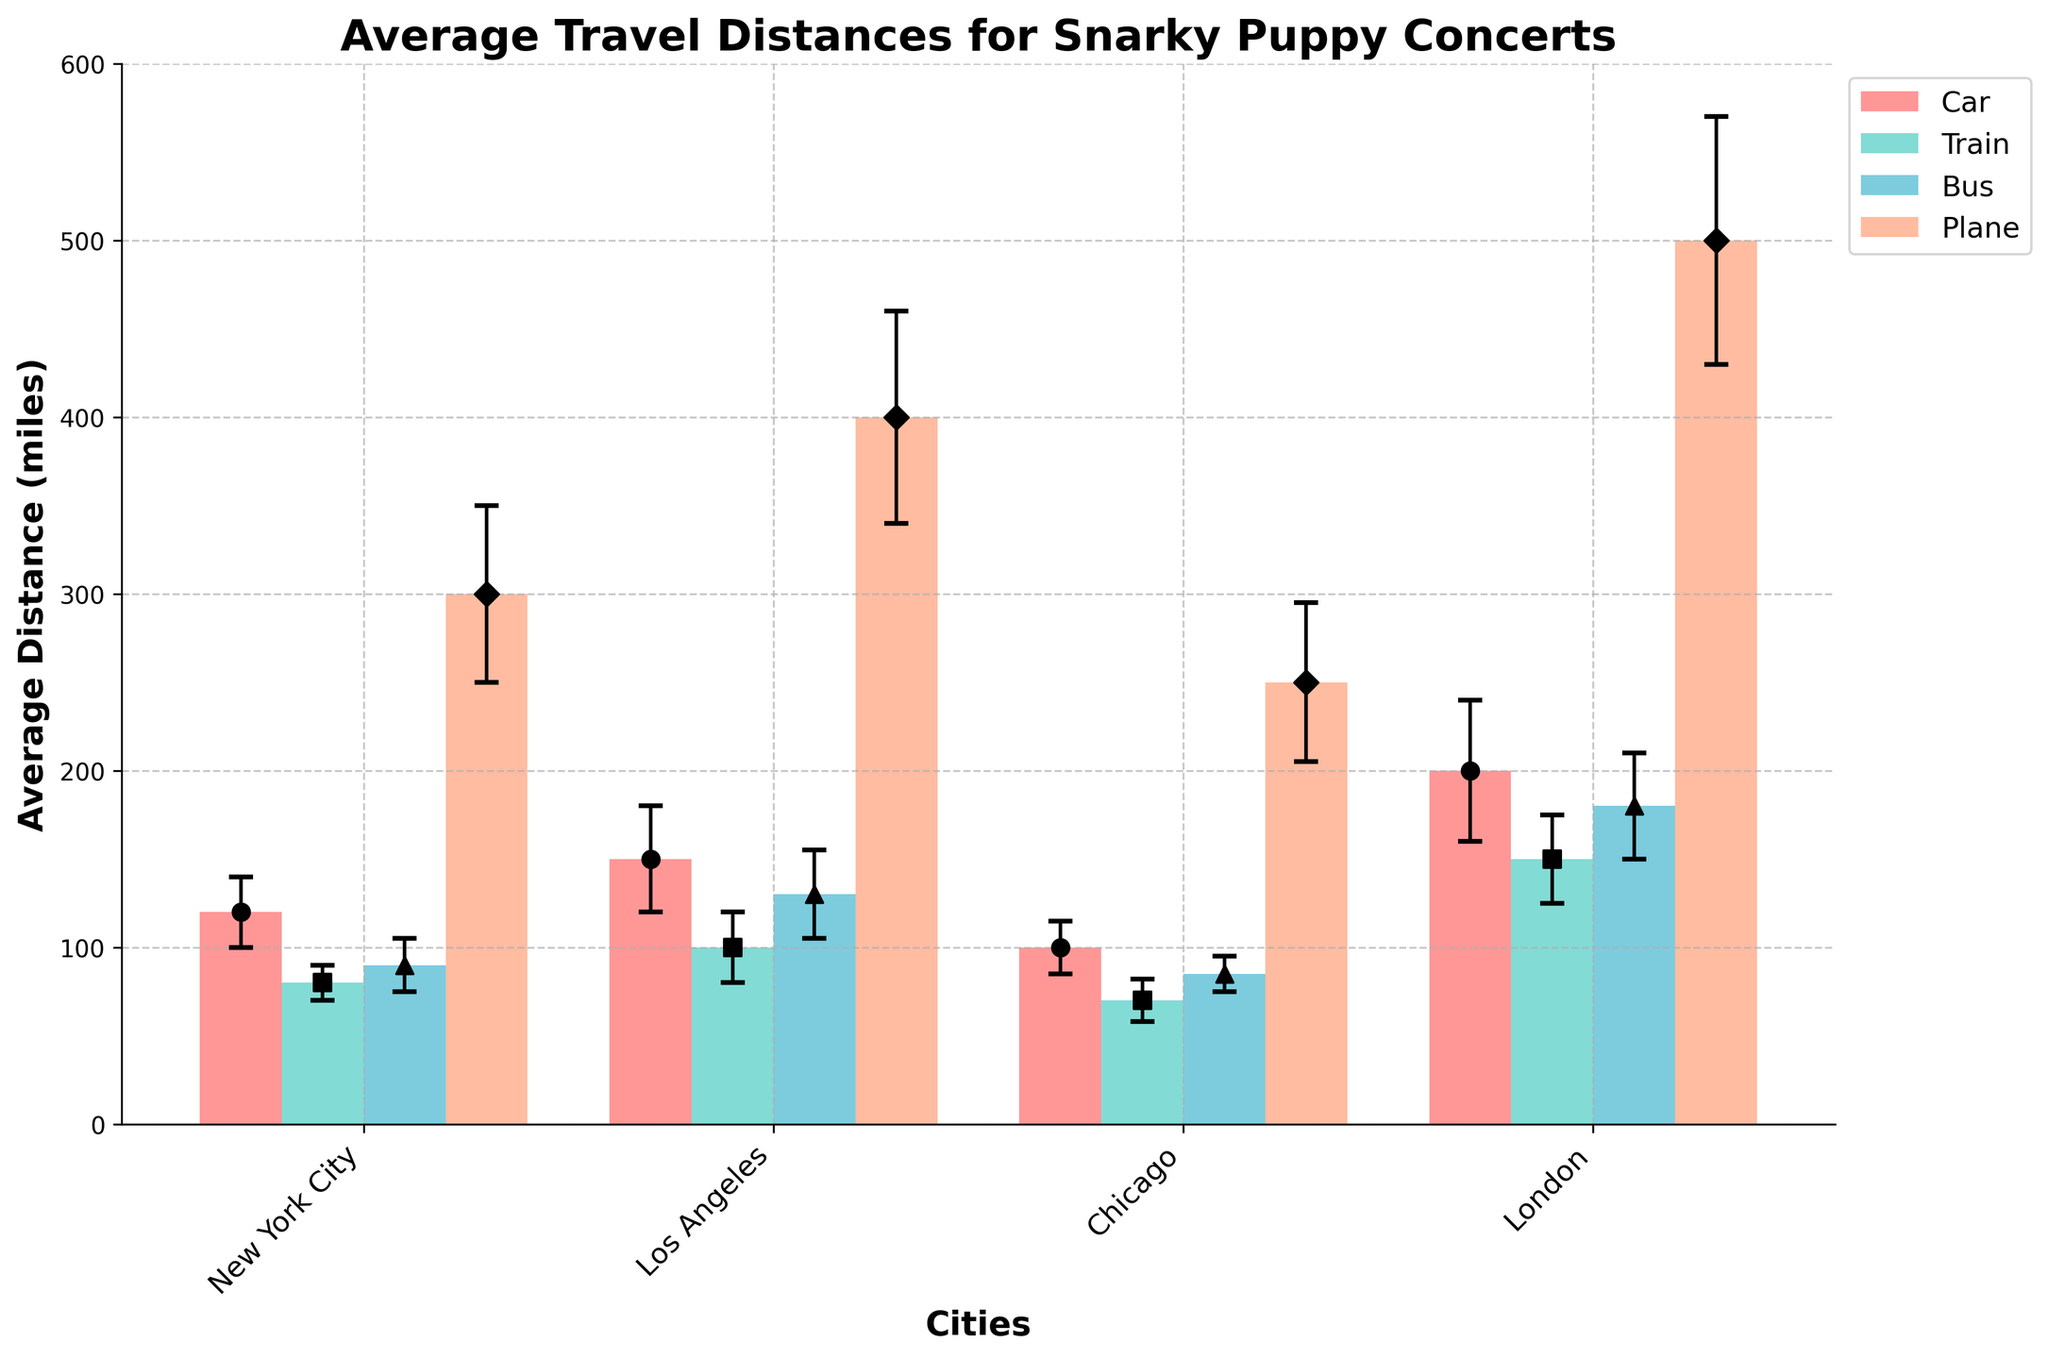What is the title of the figure? The title is usually displayed at the top of the figure. The title of this figure reads "Average Travel Distances for Snarky Puppy Concerts".
Answer: Average Travel Distances for Snarky Puppy Concerts Which mode of transportation has the highest average travel distance in London? Look at the bars for London and compare the heights for different modes of transportation. The plane bar is the highest, indicating the highest average travel distance.
Answer: Plane What is the average travel distance by train in New York City? Find the bar for the train in New York City and read the height. The average travel distance for the train in New York City is indicated as 80 miles.
Answer: 80 miles Which city has the least average travel distance when fans travel by bus? Compare the heights of the bus travel distance bars among the cities. The bar for Chicago is the shortest, indicating the least average travel distance.
Answer: Chicago How does the standard deviation of plane travel distances to Los Angeles compare to New York City? Look at the error bars for plane travel distances in both cities. The error bar (standard deviation) for Los Angeles is larger than that for New York City.
Answer: Larger What's the difference in average travel distance between car and bus in Los Angeles? Check the heights of the bars for car and bus in Los Angeles. Car has 150 miles and bus has 130 miles. The difference is 150 - 130.
Answer: 20 miles Which mode of transportation shows the highest variability in travel distances to Snarky Puppy concerts? Variability is indicated by the standard deviation, represented by error bars. The plane mode of transportation has the largest error bars, indicating the highest variability.
Answer: Plane What is the average distance for all modes of transportation in Chicago combined? Find and sum the average distances for all modes of transportation in Chicago: Car (100) + Train (70) + Bus (85) + Plane (250). The combined total is 100 + 70 + 85 + 250.
Answer: 505 miles 